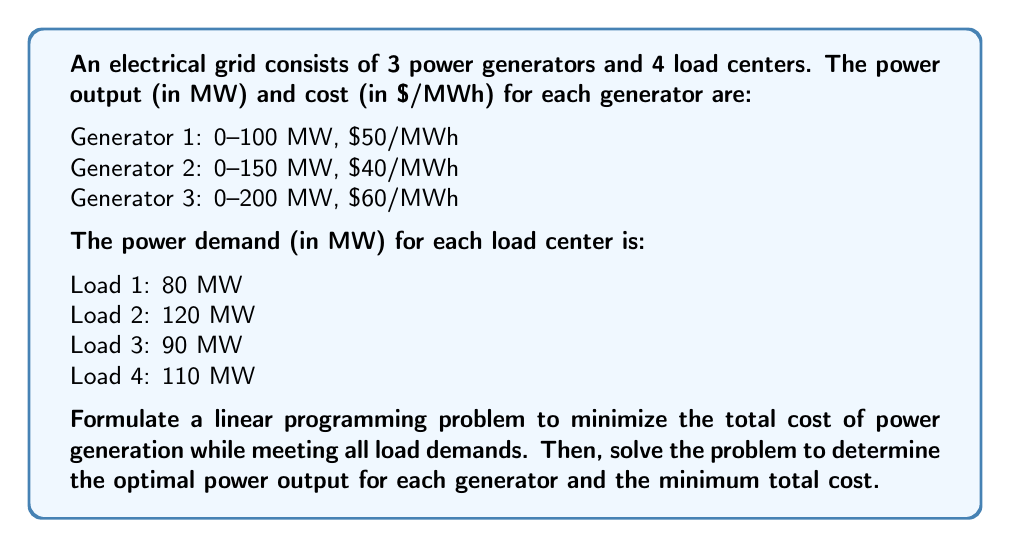Give your solution to this math problem. To solve this problem, we'll follow these steps:

1. Define decision variables
2. Formulate the objective function
3. Establish constraints
4. Solve the linear programming problem

Step 1: Define decision variables

Let $x_1$, $x_2$, and $x_3$ represent the power output (in MW) from Generators 1, 2, and 3, respectively.

Step 2: Formulate the objective function

The objective is to minimize the total cost of power generation:

$$\text{Minimize } Z = 50x_1 + 40x_2 + 60x_3$$

Step 3: Establish constraints

a) Generator capacity constraints:
$$0 \leq x_1 \leq 100$$
$$0 \leq x_2 \leq 150$$
$$0 \leq x_3 \leq 200$$

b) Load demand constraint:
$$x_1 + x_2 + x_3 = 80 + 120 + 90 + 110 = 400$$

Step 4: Solve the linear programming problem

We can solve this problem using the simplex method or a linear programming solver. The optimal solution is:

$$x_1 = 100 \text{ MW}$$
$$x_2 = 150 \text{ MW}$$
$$x_3 = 150 \text{ MW}$$

The minimum total cost is:

$$Z = 50(100) + 40(150) + 60(150) = 5000 + 6000 + 9000 = 20,000 \text{ $/h}$$

This solution utilizes the full capacity of the two cheaper generators (1 and 2) and partially uses the most expensive generator (3) to meet the total demand of 400 MW.
Answer: The optimal power output for each generator:
Generator 1: 100 MW
Generator 2: 150 MW
Generator 3: 150 MW

The minimum total cost: $20,000 per hour 